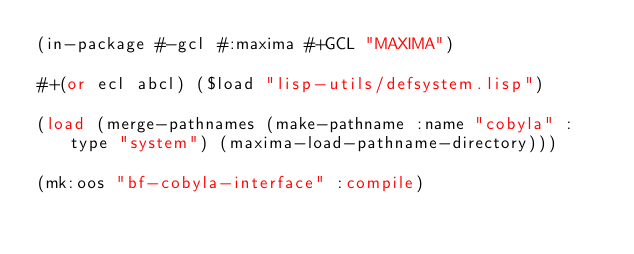<code> <loc_0><loc_0><loc_500><loc_500><_Lisp_>(in-package #-gcl #:maxima #+GCL "MAXIMA")

#+(or ecl abcl) ($load "lisp-utils/defsystem.lisp")

(load (merge-pathnames (make-pathname :name "cobyla" :type "system") (maxima-load-pathname-directory)))

(mk:oos "bf-cobyla-interface" :compile)
</code> 